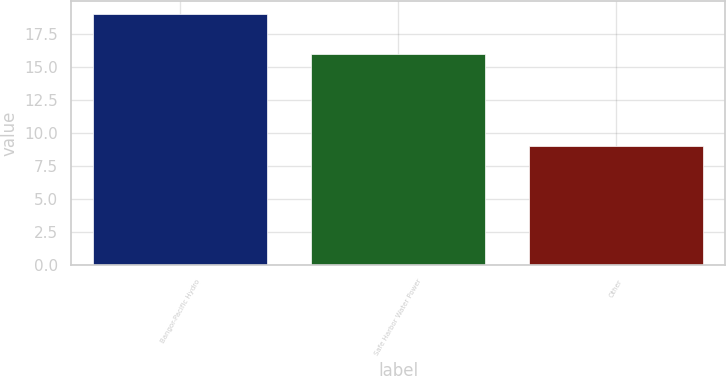Convert chart to OTSL. <chart><loc_0><loc_0><loc_500><loc_500><bar_chart><fcel>Bangor-Pacific Hydro<fcel>Safe Harbor Water Power<fcel>Other<nl><fcel>19<fcel>16<fcel>9<nl></chart> 